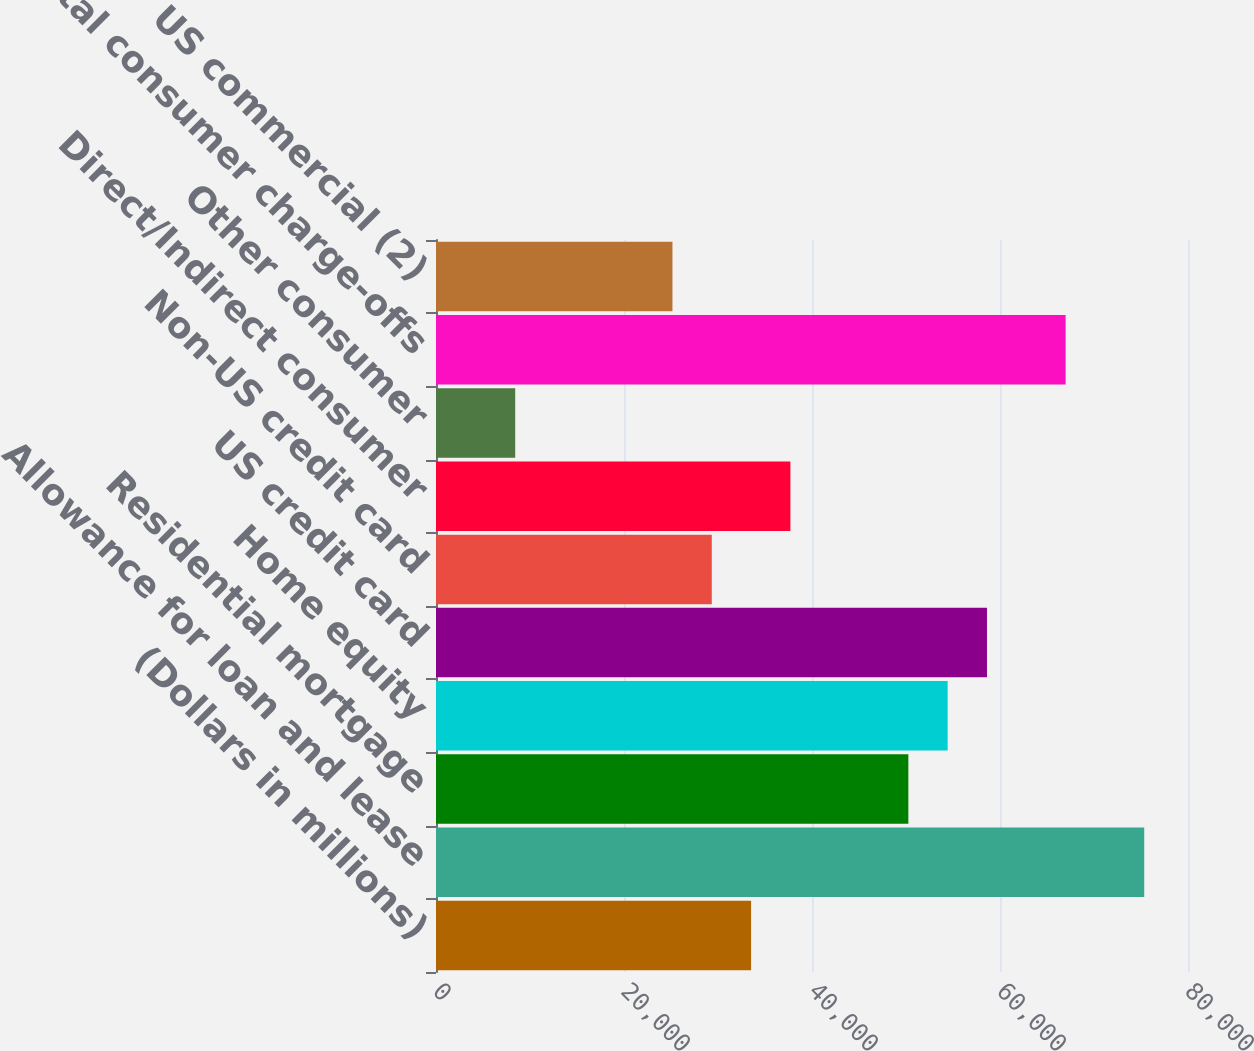<chart> <loc_0><loc_0><loc_500><loc_500><bar_chart><fcel>(Dollars in millions)<fcel>Allowance for loan and lease<fcel>Residential mortgage<fcel>Home equity<fcel>US credit card<fcel>Non-US credit card<fcel>Direct/Indirect consumer<fcel>Other consumer<fcel>Total consumer charge-offs<fcel>US commercial (2)<nl><fcel>33520.2<fcel>75344.2<fcel>50249.8<fcel>54432.2<fcel>58614.6<fcel>29337.8<fcel>37702.6<fcel>8425.8<fcel>66979.4<fcel>25155.4<nl></chart> 